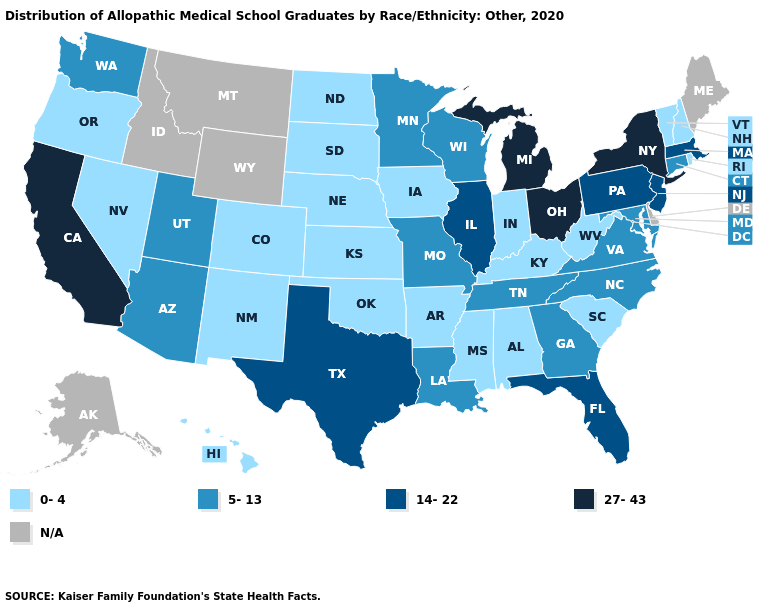What is the highest value in the Northeast ?
Write a very short answer. 27-43. Among the states that border Texas , which have the highest value?
Give a very brief answer. Louisiana. What is the value of Alabama?
Answer briefly. 0-4. Name the states that have a value in the range N/A?
Keep it brief. Alaska, Delaware, Idaho, Maine, Montana, Wyoming. Name the states that have a value in the range 27-43?
Short answer required. California, Michigan, New York, Ohio. Which states have the highest value in the USA?
Answer briefly. California, Michigan, New York, Ohio. What is the value of Connecticut?
Be succinct. 5-13. Name the states that have a value in the range 27-43?
Give a very brief answer. California, Michigan, New York, Ohio. How many symbols are there in the legend?
Write a very short answer. 5. Does California have the highest value in the USA?
Keep it brief. Yes. Is the legend a continuous bar?
Short answer required. No. Among the states that border Louisiana , does Arkansas have the lowest value?
Give a very brief answer. Yes. What is the value of Florida?
Write a very short answer. 14-22. What is the lowest value in the South?
Answer briefly. 0-4. 